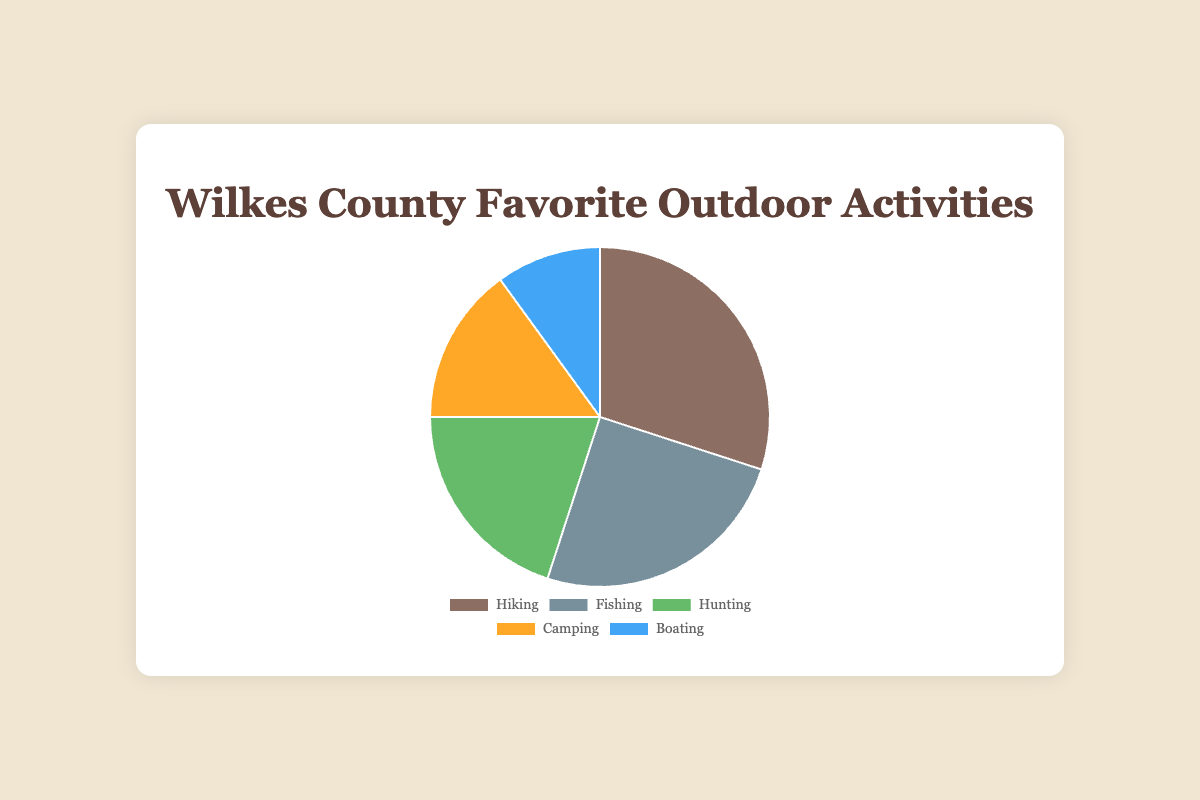Which activity is preferred by the highest percentage of Wilkes County residents? The activity with the highest percentage in the chart is the one with the largest slice. The label "Hiking" is associated with 30%, which is the largest value.
Answer: Hiking What is the total percentage of residents who prefer Camping and Boating combined? To find the combined percentage, add the percentages for Camping and Boating. Camping is 15% and Boating is 10%, so 15% + 10% = 25%.
Answer: 25% How many more residents prefer Hiking compared to Boating? To find the difference, subtract the percentage of Boating from the percentage of Hiking. Hiking is 30% and Boating is 10%, so 30% - 10% = 20%.
Answer: 20% Which activities have a lower preference than Fishing? Identify the activities with percentages less than Fishing, which is 25%. Camping at 15% and Boating at 10% are both lower.
Answer: Camping, Boating Which activity is represented by the green color in the chart? The chart shows that the green-colored slice represents the activity listed third in the legend, which is "Hunting" (20%).
Answer: Hunting Rank the activities from most preferred to least preferred. Sort the activities based on their percentages from highest to lowest. Hiking (30%), Fishing (25%), Hunting (20%), Camping (15%), Boating (10%).
Answer: Hiking, Fishing, Hunting, Camping, Boating What is the percentage difference between those who prefer Fishing and those who prefer Hunting? To find the difference, subtract the percentage of Hunting from Fishing. Fishing is 25% and Hunting is 20%, so 25% - 20% = 5%.
Answer: 5% What is the average percentage for the top three preferred activities? Calculate the sum of the percentages for Hiking, Fishing, and Hunting, then divide by 3. (30% + 25% + 20%) / 3 = 75% / 3 = 25%.
Answer: 25% What is the combined percentage of residents who prefer activities in the bottom three categories? Add the percentages for Hunting, Camping, and Boating. Hunting is 20%, Camping is 15%, and Boating is 10%. So, 20% + 15% + 10% = 45%.
Answer: 45% Which activity has the smallest slice in the pie chart? The smallest slice in the chart corresponds to the activity with the lowest percentage. The smallest percentage is 10%, which corresponds to Boating.
Answer: Boating 